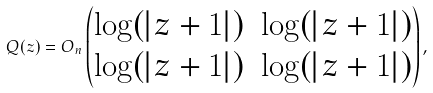<formula> <loc_0><loc_0><loc_500><loc_500>Q ( z ) = O _ { n } \left ( \begin{matrix} \log ( | z + 1 | ) & \log ( | z + 1 | ) \\ \log ( | z + 1 | ) & \log ( | z + 1 | ) \end{matrix} \right ) ,</formula> 